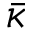Convert formula to latex. <formula><loc_0><loc_0><loc_500><loc_500>\bar { \kappa }</formula> 